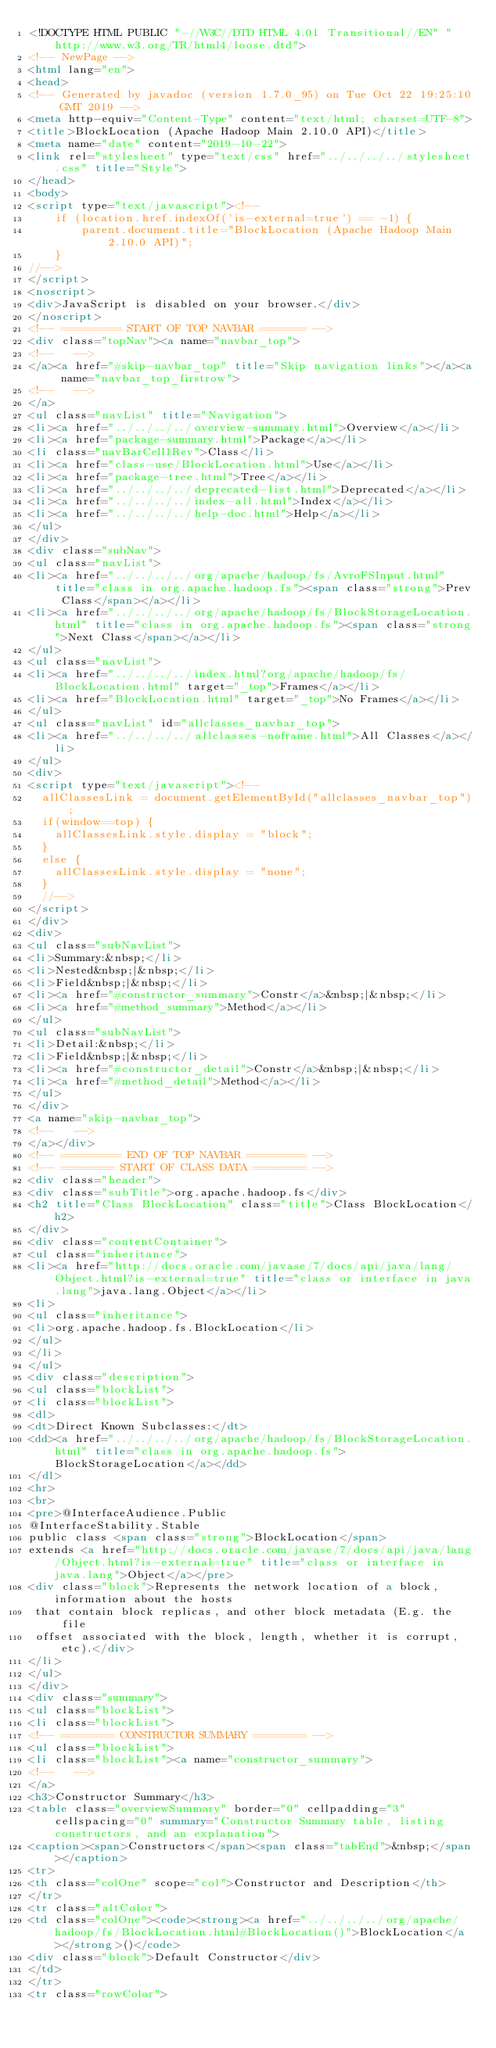Convert code to text. <code><loc_0><loc_0><loc_500><loc_500><_HTML_><!DOCTYPE HTML PUBLIC "-//W3C//DTD HTML 4.01 Transitional//EN" "http://www.w3.org/TR/html4/loose.dtd">
<!-- NewPage -->
<html lang="en">
<head>
<!-- Generated by javadoc (version 1.7.0_95) on Tue Oct 22 19:25:10 GMT 2019 -->
<meta http-equiv="Content-Type" content="text/html; charset=UTF-8">
<title>BlockLocation (Apache Hadoop Main 2.10.0 API)</title>
<meta name="date" content="2019-10-22">
<link rel="stylesheet" type="text/css" href="../../../../stylesheet.css" title="Style">
</head>
<body>
<script type="text/javascript"><!--
    if (location.href.indexOf('is-external=true') == -1) {
        parent.document.title="BlockLocation (Apache Hadoop Main 2.10.0 API)";
    }
//-->
</script>
<noscript>
<div>JavaScript is disabled on your browser.</div>
</noscript>
<!-- ========= START OF TOP NAVBAR ======= -->
<div class="topNav"><a name="navbar_top">
<!--   -->
</a><a href="#skip-navbar_top" title="Skip navigation links"></a><a name="navbar_top_firstrow">
<!--   -->
</a>
<ul class="navList" title="Navigation">
<li><a href="../../../../overview-summary.html">Overview</a></li>
<li><a href="package-summary.html">Package</a></li>
<li class="navBarCell1Rev">Class</li>
<li><a href="class-use/BlockLocation.html">Use</a></li>
<li><a href="package-tree.html">Tree</a></li>
<li><a href="../../../../deprecated-list.html">Deprecated</a></li>
<li><a href="../../../../index-all.html">Index</a></li>
<li><a href="../../../../help-doc.html">Help</a></li>
</ul>
</div>
<div class="subNav">
<ul class="navList">
<li><a href="../../../../org/apache/hadoop/fs/AvroFSInput.html" title="class in org.apache.hadoop.fs"><span class="strong">Prev Class</span></a></li>
<li><a href="../../../../org/apache/hadoop/fs/BlockStorageLocation.html" title="class in org.apache.hadoop.fs"><span class="strong">Next Class</span></a></li>
</ul>
<ul class="navList">
<li><a href="../../../../index.html?org/apache/hadoop/fs/BlockLocation.html" target="_top">Frames</a></li>
<li><a href="BlockLocation.html" target="_top">No Frames</a></li>
</ul>
<ul class="navList" id="allclasses_navbar_top">
<li><a href="../../../../allclasses-noframe.html">All Classes</a></li>
</ul>
<div>
<script type="text/javascript"><!--
  allClassesLink = document.getElementById("allclasses_navbar_top");
  if(window==top) {
    allClassesLink.style.display = "block";
  }
  else {
    allClassesLink.style.display = "none";
  }
  //-->
</script>
</div>
<div>
<ul class="subNavList">
<li>Summary:&nbsp;</li>
<li>Nested&nbsp;|&nbsp;</li>
<li>Field&nbsp;|&nbsp;</li>
<li><a href="#constructor_summary">Constr</a>&nbsp;|&nbsp;</li>
<li><a href="#method_summary">Method</a></li>
</ul>
<ul class="subNavList">
<li>Detail:&nbsp;</li>
<li>Field&nbsp;|&nbsp;</li>
<li><a href="#constructor_detail">Constr</a>&nbsp;|&nbsp;</li>
<li><a href="#method_detail">Method</a></li>
</ul>
</div>
<a name="skip-navbar_top">
<!--   -->
</a></div>
<!-- ========= END OF TOP NAVBAR ========= -->
<!-- ======== START OF CLASS DATA ======== -->
<div class="header">
<div class="subTitle">org.apache.hadoop.fs</div>
<h2 title="Class BlockLocation" class="title">Class BlockLocation</h2>
</div>
<div class="contentContainer">
<ul class="inheritance">
<li><a href="http://docs.oracle.com/javase/7/docs/api/java/lang/Object.html?is-external=true" title="class or interface in java.lang">java.lang.Object</a></li>
<li>
<ul class="inheritance">
<li>org.apache.hadoop.fs.BlockLocation</li>
</ul>
</li>
</ul>
<div class="description">
<ul class="blockList">
<li class="blockList">
<dl>
<dt>Direct Known Subclasses:</dt>
<dd><a href="../../../../org/apache/hadoop/fs/BlockStorageLocation.html" title="class in org.apache.hadoop.fs">BlockStorageLocation</a></dd>
</dl>
<hr>
<br>
<pre>@InterfaceAudience.Public
@InterfaceStability.Stable
public class <span class="strong">BlockLocation</span>
extends <a href="http://docs.oracle.com/javase/7/docs/api/java/lang/Object.html?is-external=true" title="class or interface in java.lang">Object</a></pre>
<div class="block">Represents the network location of a block, information about the hosts
 that contain block replicas, and other block metadata (E.g. the file
 offset associated with the block, length, whether it is corrupt, etc).</div>
</li>
</ul>
</div>
<div class="summary">
<ul class="blockList">
<li class="blockList">
<!-- ======== CONSTRUCTOR SUMMARY ======== -->
<ul class="blockList">
<li class="blockList"><a name="constructor_summary">
<!--   -->
</a>
<h3>Constructor Summary</h3>
<table class="overviewSummary" border="0" cellpadding="3" cellspacing="0" summary="Constructor Summary table, listing constructors, and an explanation">
<caption><span>Constructors</span><span class="tabEnd">&nbsp;</span></caption>
<tr>
<th class="colOne" scope="col">Constructor and Description</th>
</tr>
<tr class="altColor">
<td class="colOne"><code><strong><a href="../../../../org/apache/hadoop/fs/BlockLocation.html#BlockLocation()">BlockLocation</a></strong>()</code>
<div class="block">Default Constructor</div>
</td>
</tr>
<tr class="rowColor"></code> 